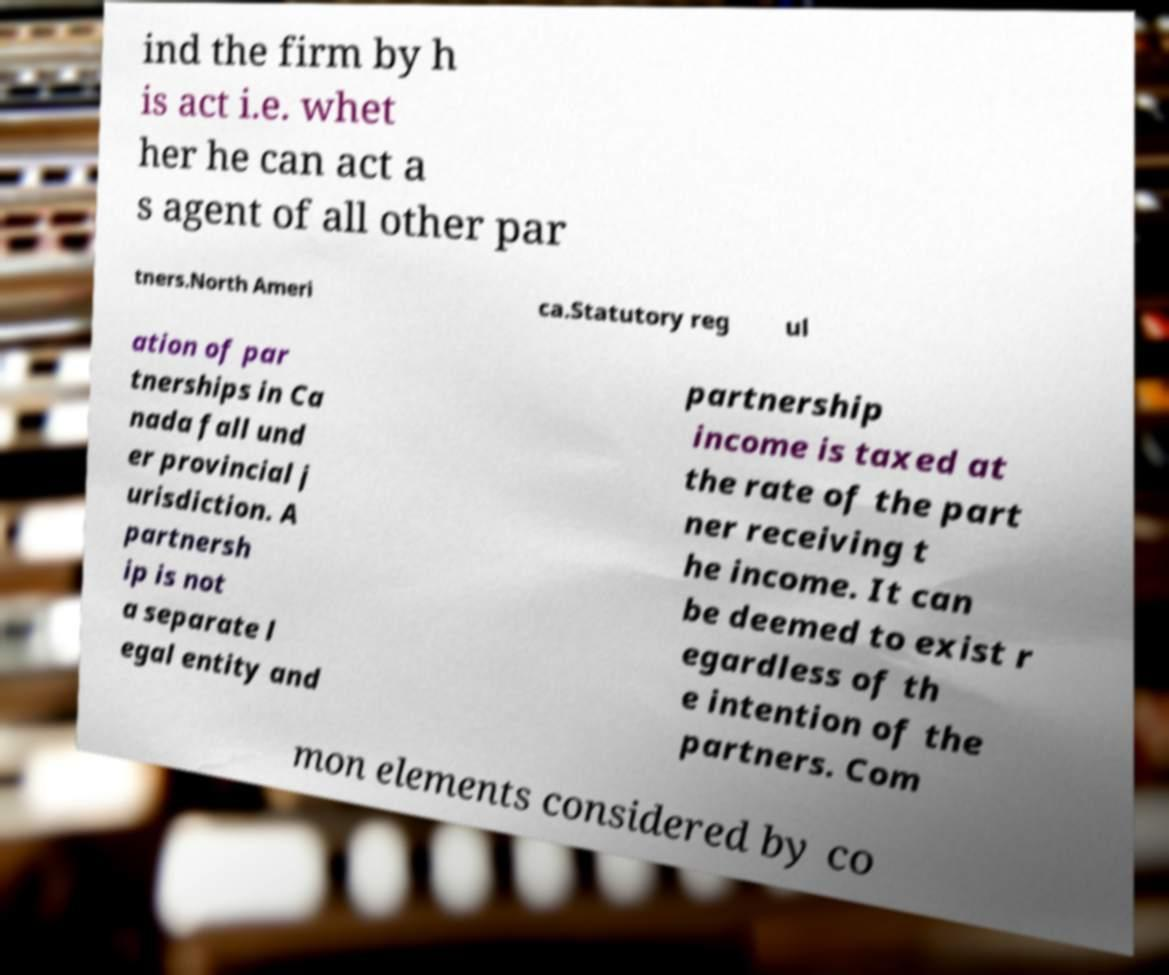Could you extract and type out the text from this image? ind the firm by h is act i.e. whet her he can act a s agent of all other par tners.North Ameri ca.Statutory reg ul ation of par tnerships in Ca nada fall und er provincial j urisdiction. A partnersh ip is not a separate l egal entity and partnership income is taxed at the rate of the part ner receiving t he income. It can be deemed to exist r egardless of th e intention of the partners. Com mon elements considered by co 